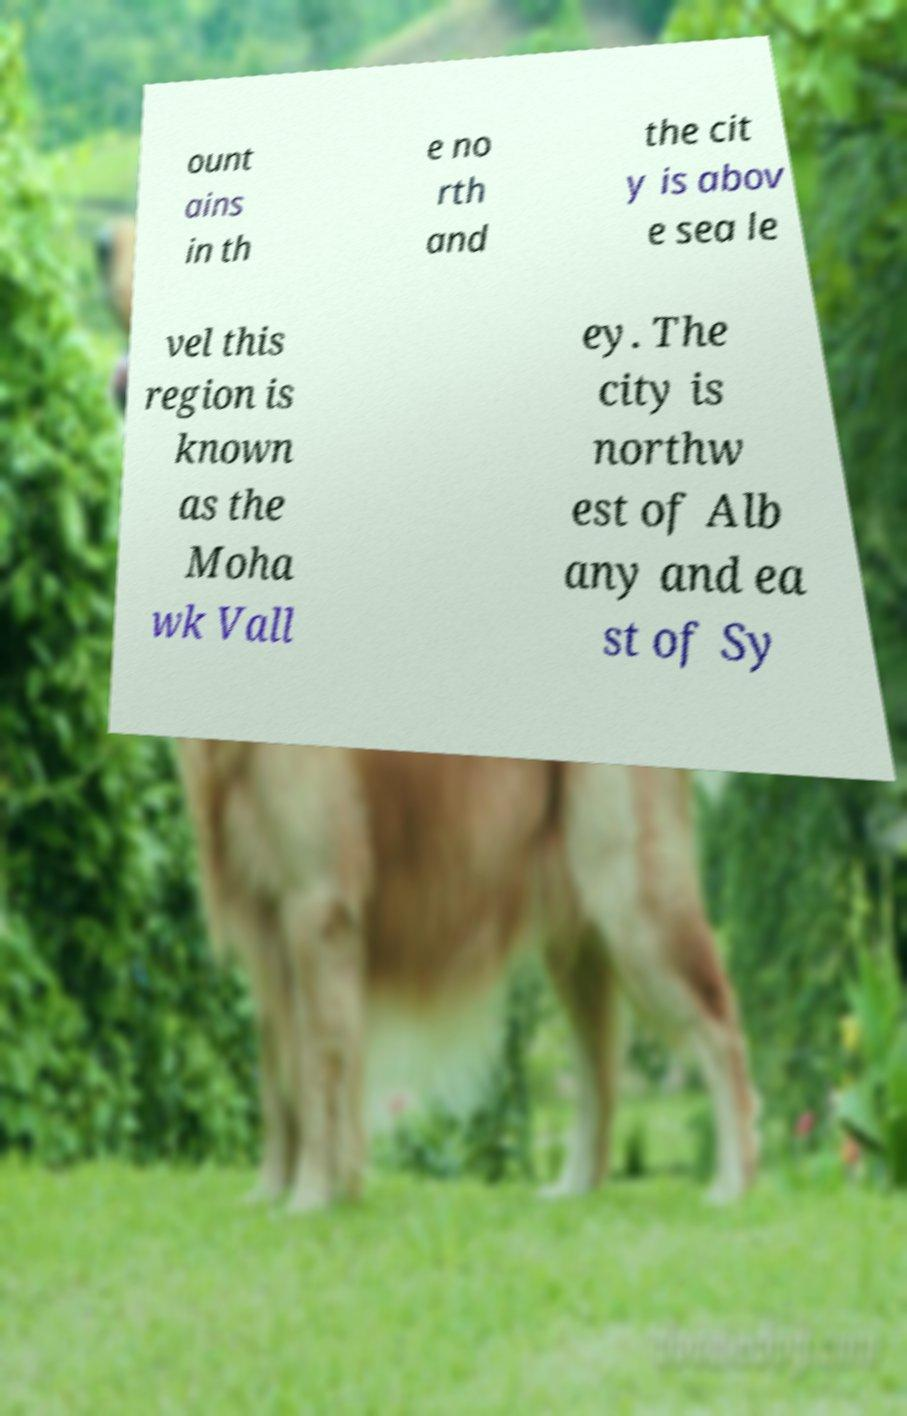For documentation purposes, I need the text within this image transcribed. Could you provide that? ount ains in th e no rth and the cit y is abov e sea le vel this region is known as the Moha wk Vall ey. The city is northw est of Alb any and ea st of Sy 